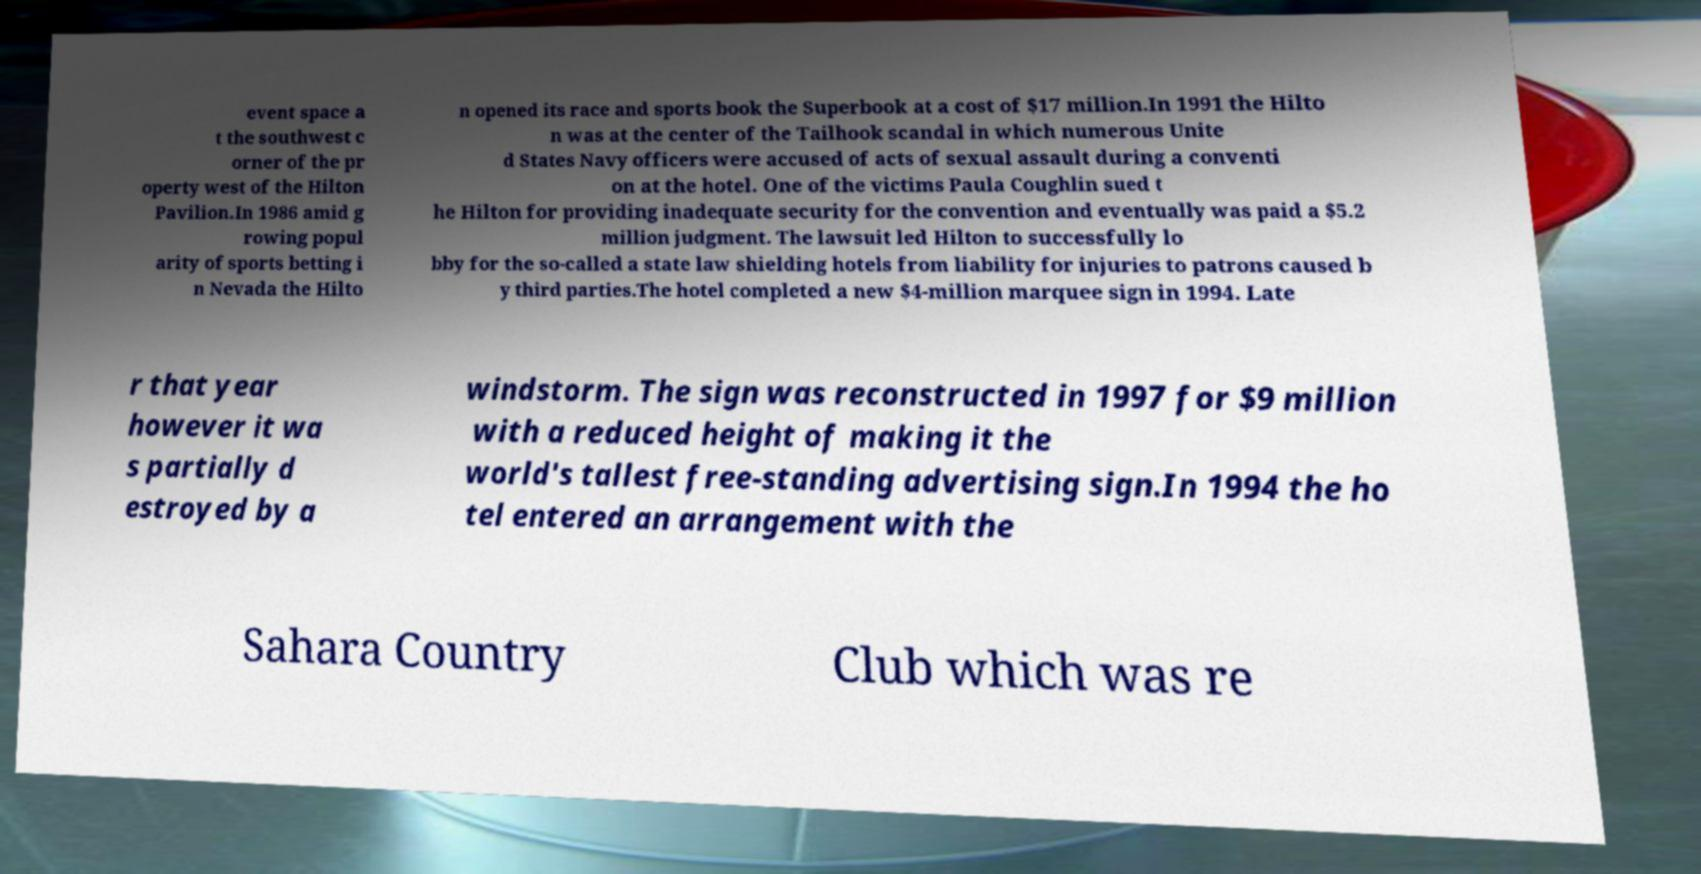Could you extract and type out the text from this image? event space a t the southwest c orner of the pr operty west of the Hilton Pavilion.In 1986 amid g rowing popul arity of sports betting i n Nevada the Hilto n opened its race and sports book the Superbook at a cost of $17 million.In 1991 the Hilto n was at the center of the Tailhook scandal in which numerous Unite d States Navy officers were accused of acts of sexual assault during a conventi on at the hotel. One of the victims Paula Coughlin sued t he Hilton for providing inadequate security for the convention and eventually was paid a $5.2 million judgment. The lawsuit led Hilton to successfully lo bby for the so-called a state law shielding hotels from liability for injuries to patrons caused b y third parties.The hotel completed a new $4-million marquee sign in 1994. Late r that year however it wa s partially d estroyed by a windstorm. The sign was reconstructed in 1997 for $9 million with a reduced height of making it the world's tallest free-standing advertising sign.In 1994 the ho tel entered an arrangement with the Sahara Country Club which was re 